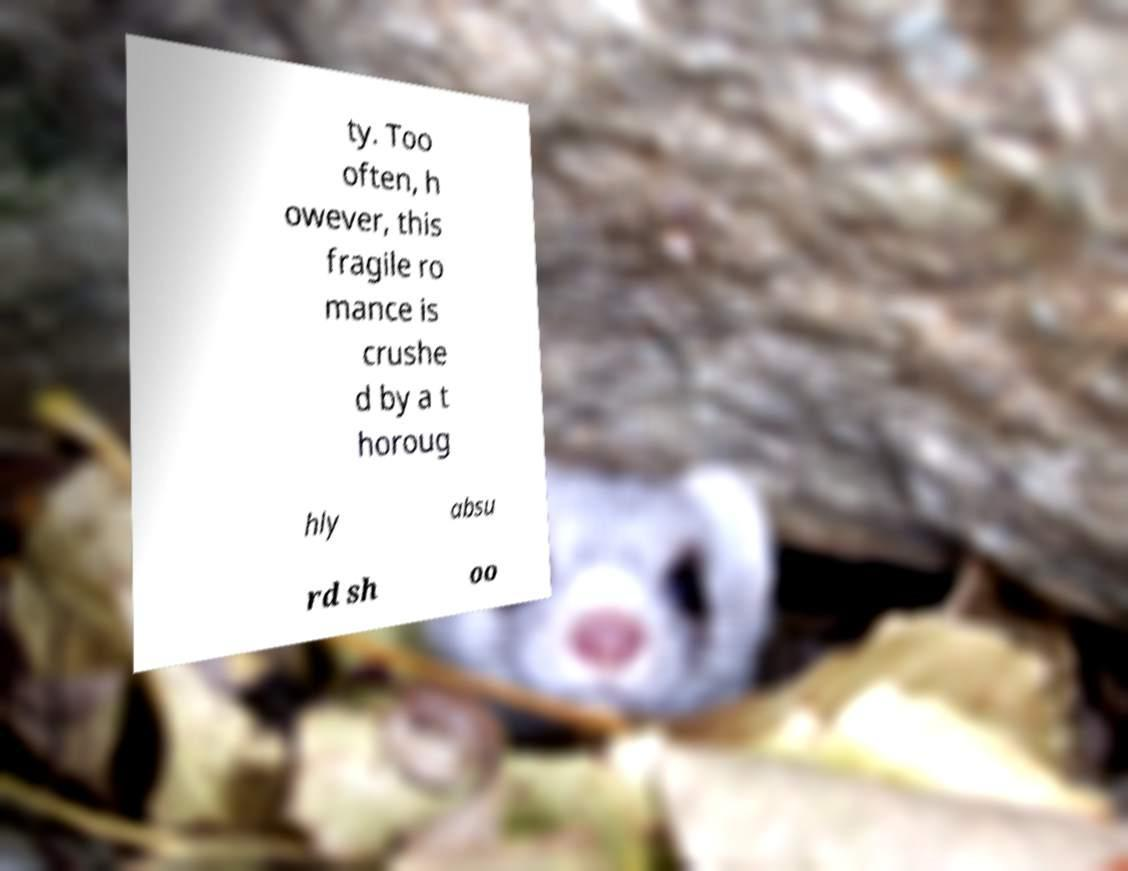Can you accurately transcribe the text from the provided image for me? ty. Too often, h owever, this fragile ro mance is crushe d by a t horoug hly absu rd sh oo 